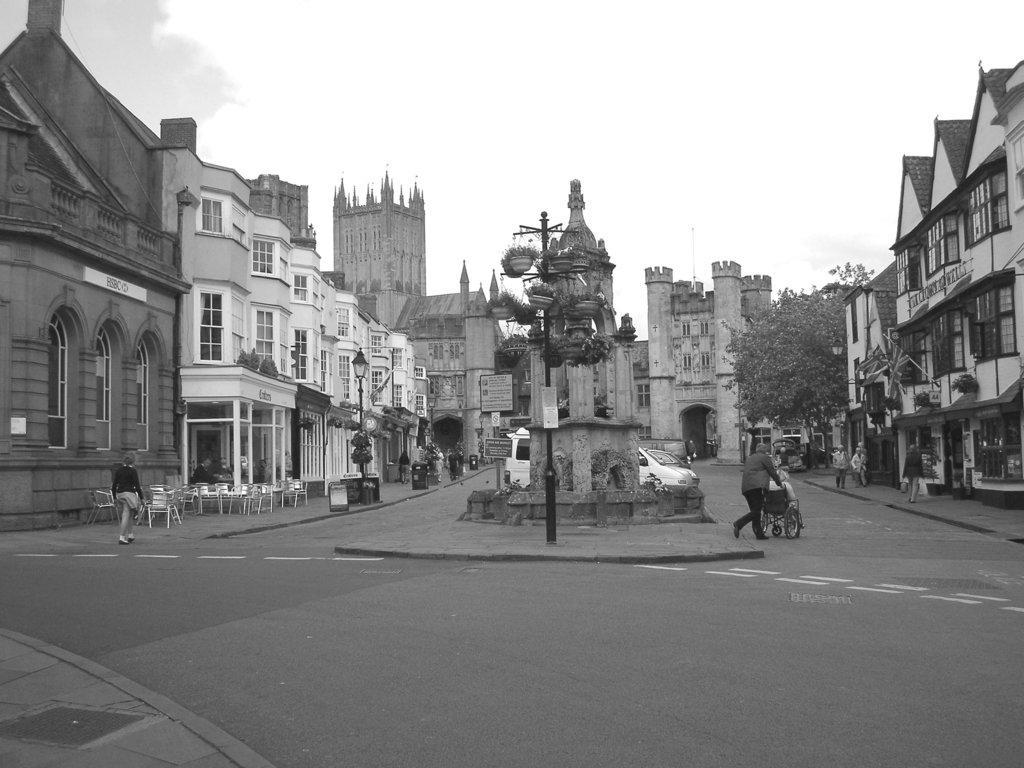Describe this image in one or two sentences. In the image I can see a place where we have some buildings, poles and also I can see some people, chairs and some other things. 